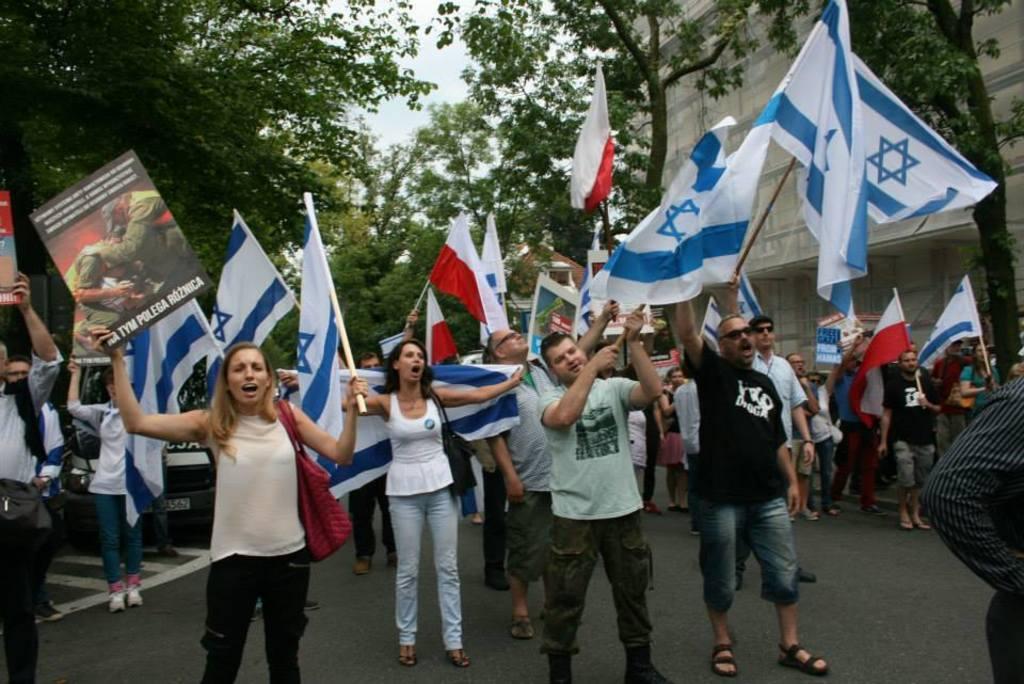Could you give a brief overview of what you see in this image? In this picture there is a group of men and women, standing on the street holding the white and blue color flag in the hand. In the front there is a girl holding the poster. Behind there are some trees and white color building wall. 